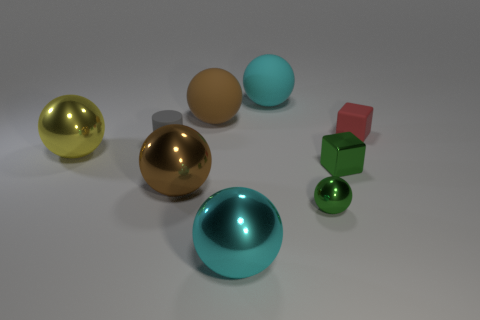Subtract all big yellow shiny balls. How many balls are left? 5 Add 1 yellow shiny things. How many objects exist? 10 Subtract 1 cylinders. How many cylinders are left? 0 Subtract all blocks. How many objects are left? 7 Subtract all yellow spheres. How many spheres are left? 5 Subtract all red cubes. How many brown balls are left? 2 Subtract 0 yellow blocks. How many objects are left? 9 Subtract all green cubes. Subtract all purple balls. How many cubes are left? 1 Subtract all big cyan matte spheres. Subtract all yellow balls. How many objects are left? 7 Add 3 tiny metallic balls. How many tiny metallic balls are left? 4 